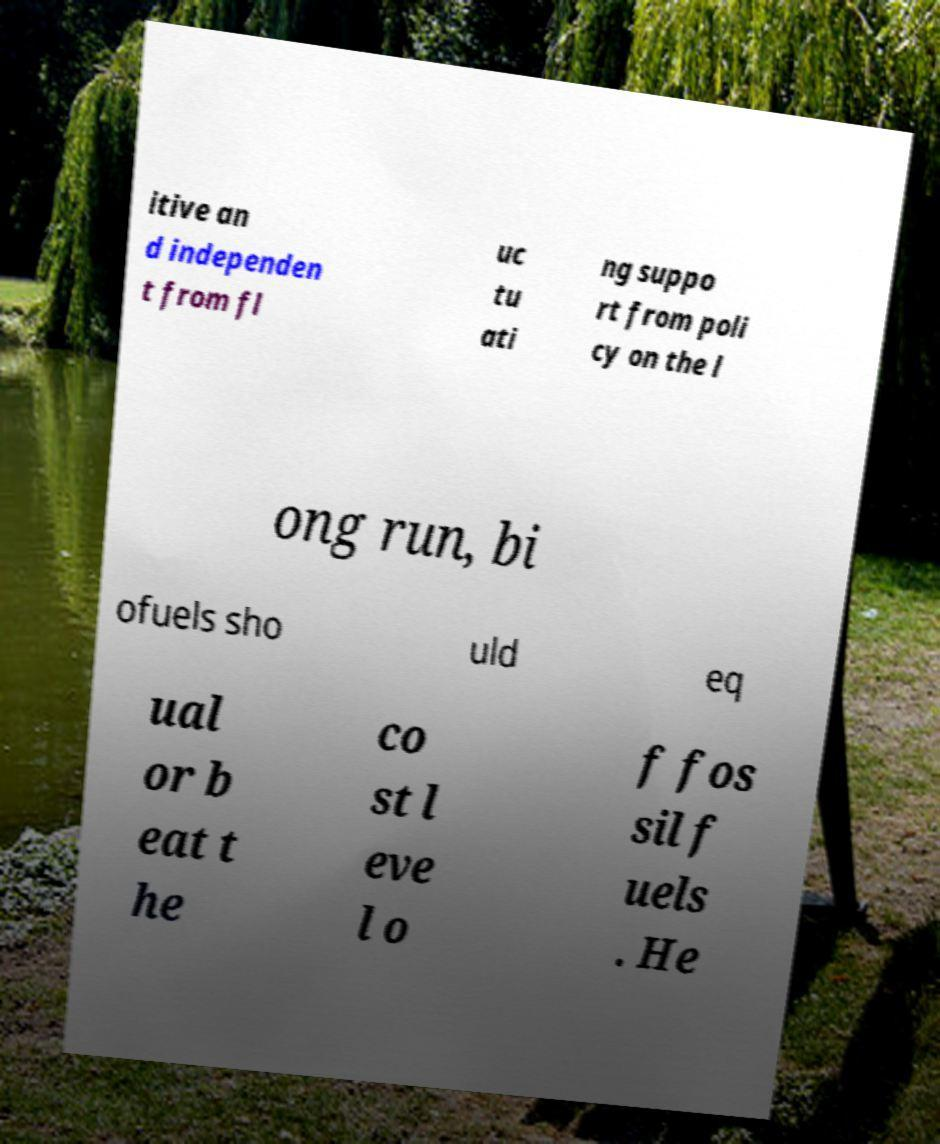Please read and relay the text visible in this image. What does it say? itive an d independen t from fl uc tu ati ng suppo rt from poli cy on the l ong run, bi ofuels sho uld eq ual or b eat t he co st l eve l o f fos sil f uels . He 